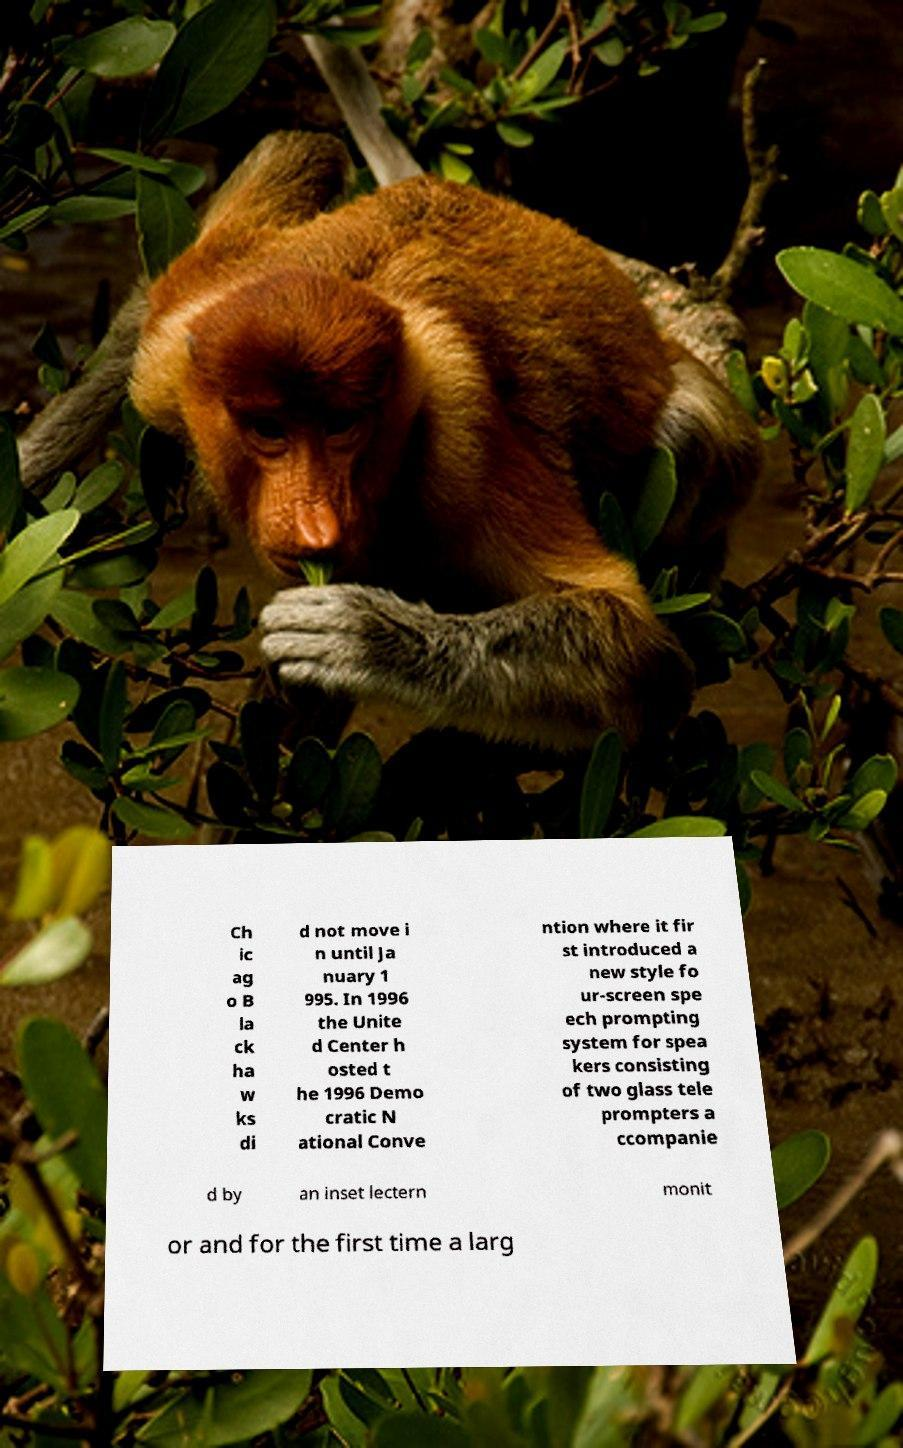I need the written content from this picture converted into text. Can you do that? Ch ic ag o B la ck ha w ks di d not move i n until Ja nuary 1 995. In 1996 the Unite d Center h osted t he 1996 Demo cratic N ational Conve ntion where it fir st introduced a new style fo ur-screen spe ech prompting system for spea kers consisting of two glass tele prompters a ccompanie d by an inset lectern monit or and for the first time a larg 